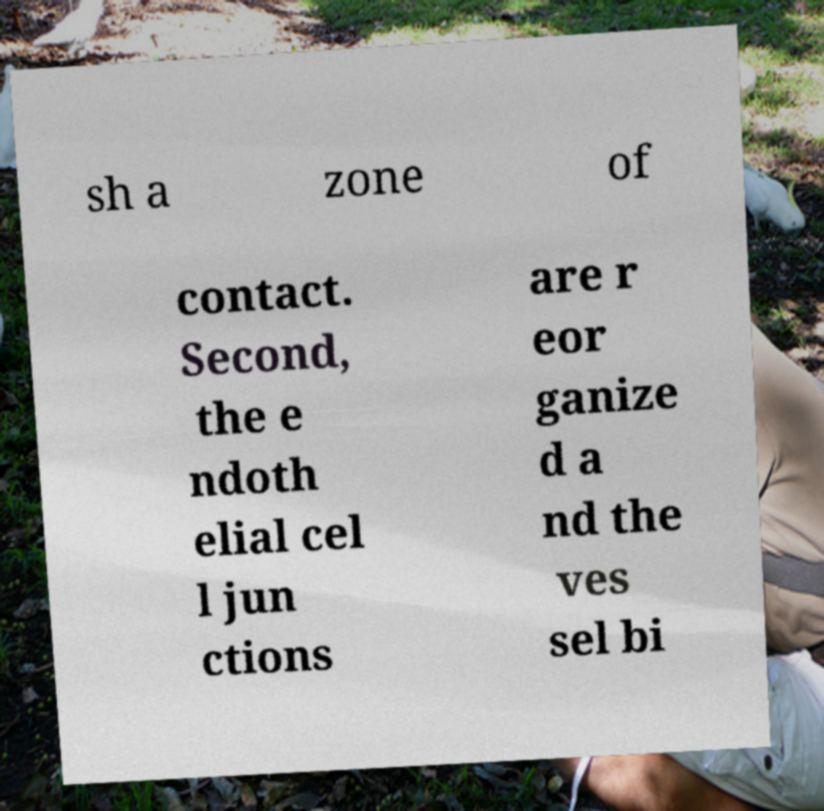Please read and relay the text visible in this image. What does it say? sh a zone of contact. Second, the e ndoth elial cel l jun ctions are r eor ganize d a nd the ves sel bi 